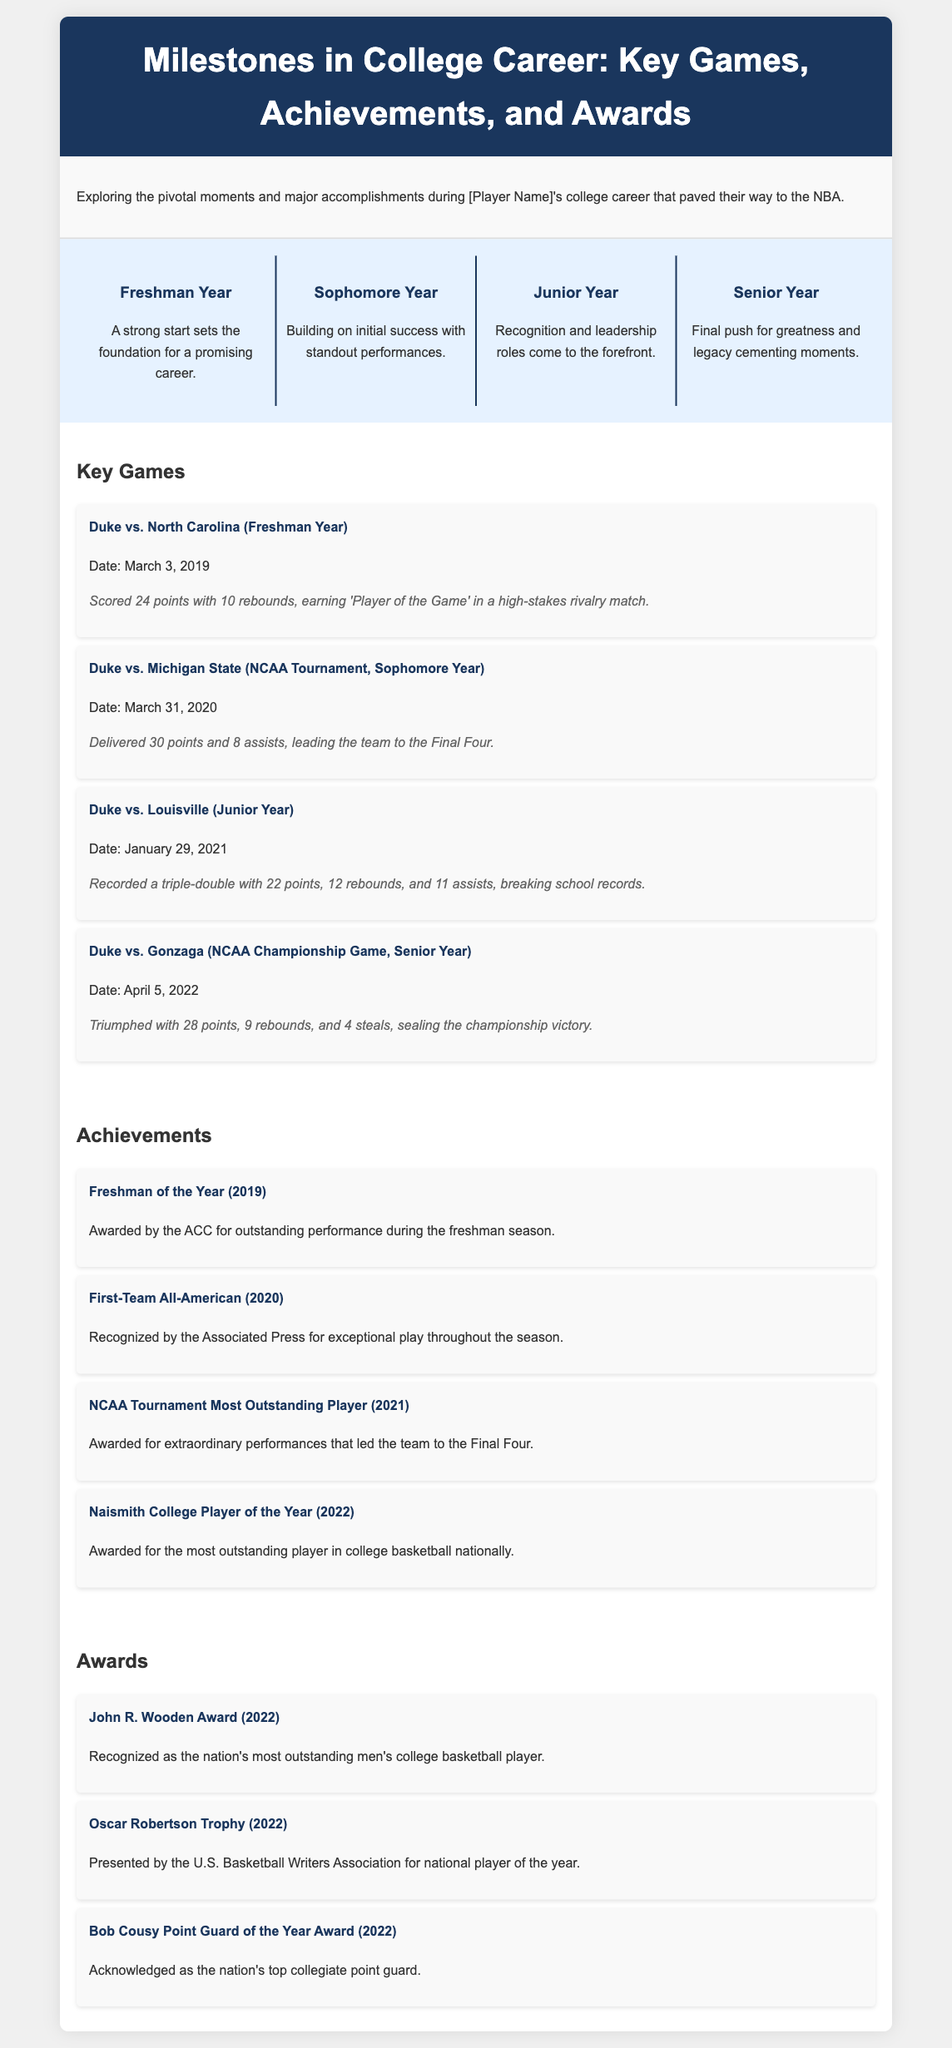What was the score in the key game against North Carolina? The score in the key game against North Carolina is highlighted in the milestone section which mentions the player scored 24 points.
Answer: 24 points What award did the player receive in 2022? The document lists several awards in the awards section, one of which the player received in 2022 is the John R. Wooden Award.
Answer: John R. Wooden Award How many points did the player score in the NCAA Championship Game? The achievement of scoring in the NCAA Championship Game against Gonzaga is stated in the key games section as 28 points.
Answer: 28 points What year did the player win the Freshman of the Year award? The award is mentioned in the achievements section, which states that the player was awarded Freshman of the Year in 2019.
Answer: 2019 In which year did the player record a triple-double? The key game against Louisville recorded a triple-double, and the document states this occurred in January 2021 as part of the junior year.
Answer: Junior Year What was the player's contribution in the game against Michigan State? The document specifies the player's contribution as delivering 30 points and 8 assists in the NCAA Tournament game against Michigan State.
Answer: 30 points and 8 assists What is the primary focus of the document? The document's main theme is exploring key moments of the player’s college career leading to the NBA.
Answer: Milestones in College Career How many key games are highlighted in the document? The key games section lists a total of four significant games throughout the player's college career.
Answer: Four games What was the date of the championship game? The championship game date is given in the context of the key games, specifically, it was played on April 5, 2022.
Answer: April 5, 2022 